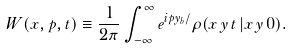<formula> <loc_0><loc_0><loc_500><loc_500>W ( x , p , t ) \equiv \frac { 1 } { 2 \pi } \int _ { - \infty } ^ { \infty } e ^ { i p y _ { b } / } \rho ( x \, y \, t \, | x \, y \, 0 ) .</formula> 